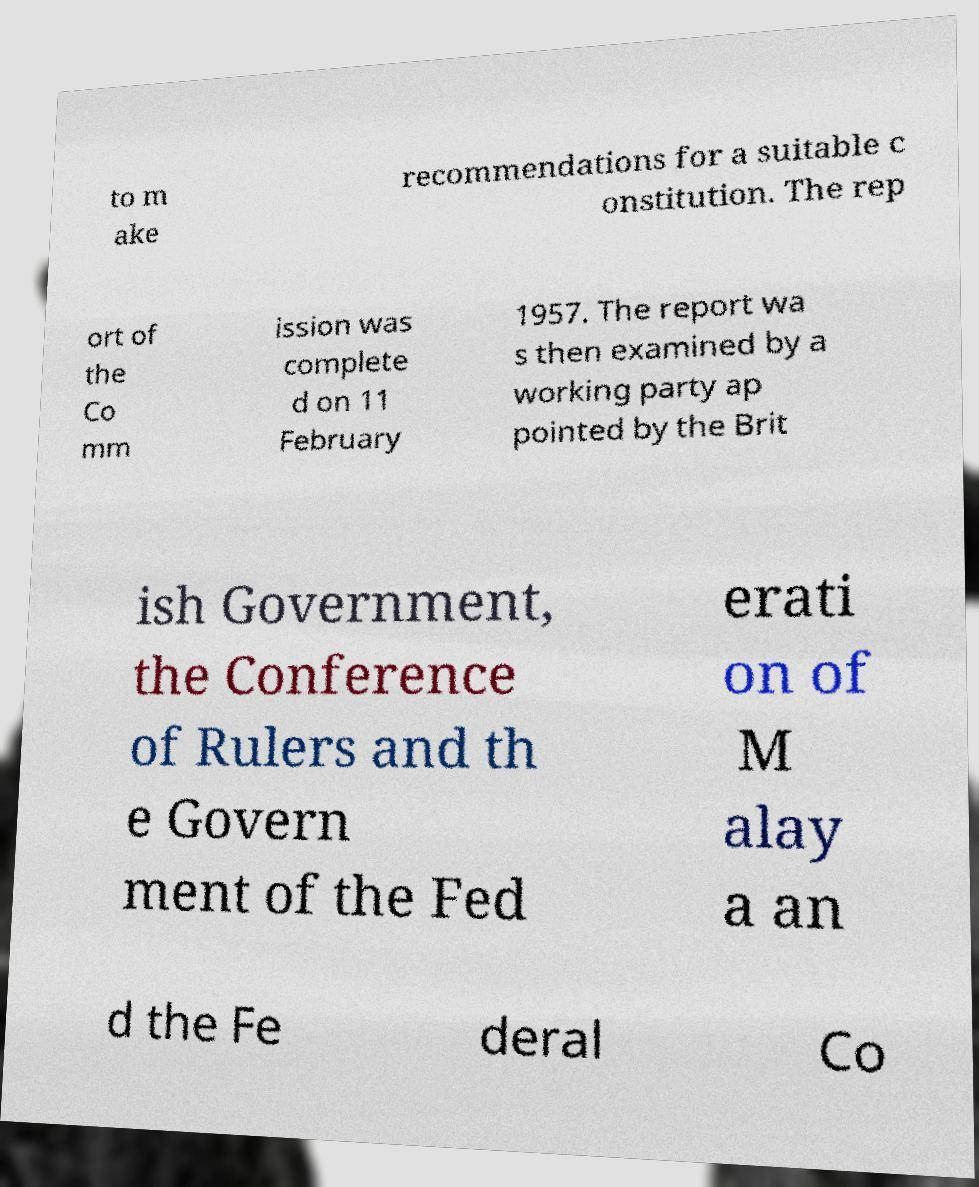Please identify and transcribe the text found in this image. to m ake recommendations for a suitable c onstitution. The rep ort of the Co mm ission was complete d on 11 February 1957. The report wa s then examined by a working party ap pointed by the Brit ish Government, the Conference of Rulers and th e Govern ment of the Fed erati on of M alay a an d the Fe deral Co 